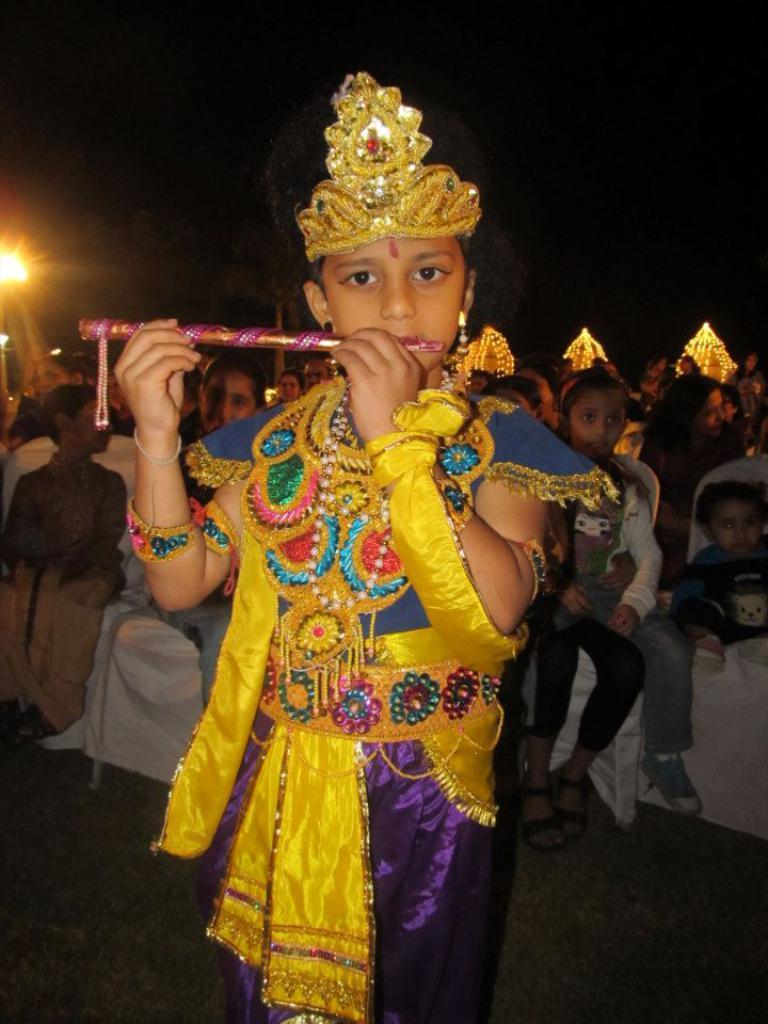Who is the main subject in the image? There is a boy in the image. What is the boy wearing? The boy is wearing a fancy costume. What can be seen in the background of the image? There are people sitting on chairs in the background. Where is the light source located in the image? There is a light on the left side of the image. What type of crown can be seen on the boy's head in the image? There is no crown visible on the boy's head in the image. What is the taste of the ray that is swimming in the background? There are no rays or any aquatic animals present in the image; it features a boy wearing a fancy costume and people sitting on chairs in the background. 